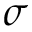Convert formula to latex. <formula><loc_0><loc_0><loc_500><loc_500>\sigma</formula> 